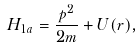<formula> <loc_0><loc_0><loc_500><loc_500>H _ { 1 a } = \frac { p ^ { 2 } } { 2 m } + U ( r ) ,</formula> 